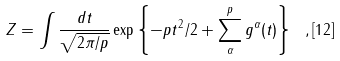<formula> <loc_0><loc_0><loc_500><loc_500>Z = \int \frac { d t } { \sqrt { 2 \pi / p } } \exp \left \{ - p t ^ { 2 } / 2 + \sum _ { \alpha } ^ { p } g ^ { \alpha } ( t ) \right \} \ , { [ 1 2 ] }</formula> 